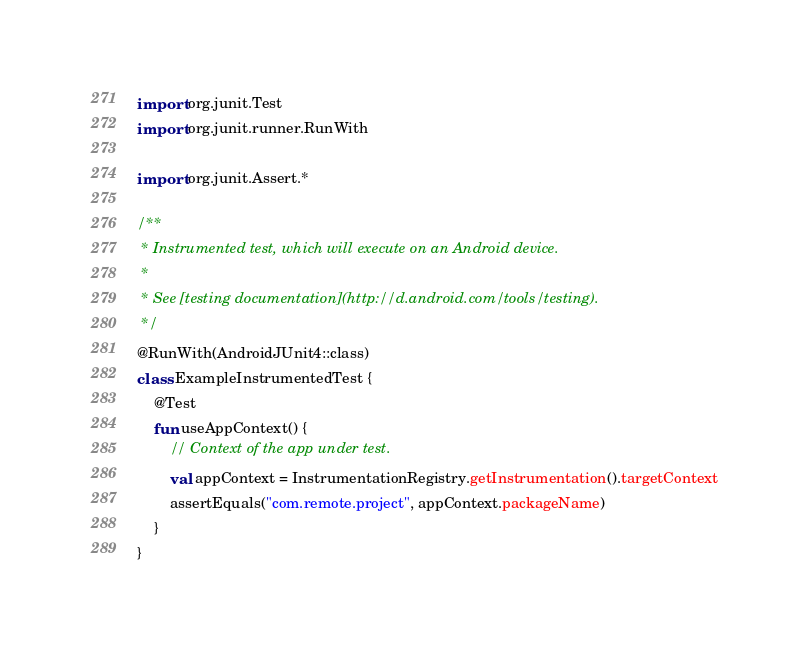Convert code to text. <code><loc_0><loc_0><loc_500><loc_500><_Kotlin_>
import org.junit.Test
import org.junit.runner.RunWith

import org.junit.Assert.*

/**
 * Instrumented test, which will execute on an Android device.
 *
 * See [testing documentation](http://d.android.com/tools/testing).
 */
@RunWith(AndroidJUnit4::class)
class ExampleInstrumentedTest {
    @Test
    fun useAppContext() {
        // Context of the app under test.
        val appContext = InstrumentationRegistry.getInstrumentation().targetContext
        assertEquals("com.remote.project", appContext.packageName)
    }
}
</code> 